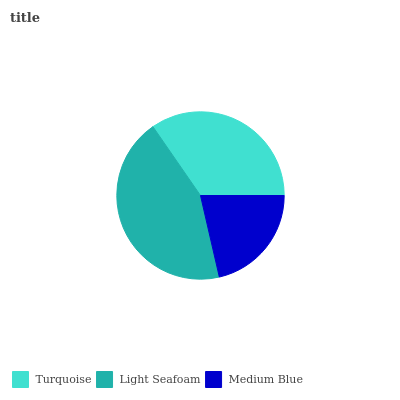Is Medium Blue the minimum?
Answer yes or no. Yes. Is Light Seafoam the maximum?
Answer yes or no. Yes. Is Light Seafoam the minimum?
Answer yes or no. No. Is Medium Blue the maximum?
Answer yes or no. No. Is Light Seafoam greater than Medium Blue?
Answer yes or no. Yes. Is Medium Blue less than Light Seafoam?
Answer yes or no. Yes. Is Medium Blue greater than Light Seafoam?
Answer yes or no. No. Is Light Seafoam less than Medium Blue?
Answer yes or no. No. Is Turquoise the high median?
Answer yes or no. Yes. Is Turquoise the low median?
Answer yes or no. Yes. Is Medium Blue the high median?
Answer yes or no. No. Is Light Seafoam the low median?
Answer yes or no. No. 